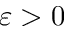Convert formula to latex. <formula><loc_0><loc_0><loc_500><loc_500>\varepsilon > 0</formula> 